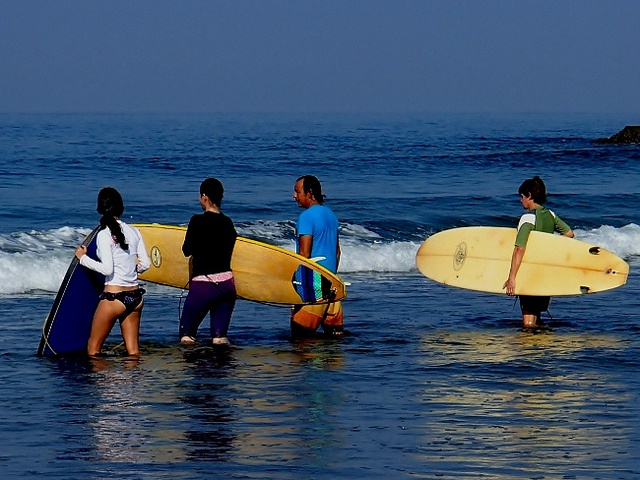Describe the objects in this image and their specific colors. I can see surfboard in blue, khaki, and tan tones, people in blue, black, lightgray, brown, and maroon tones, people in blue, black, lightpink, and navy tones, surfboard in blue, olive, tan, and orange tones, and people in blue, black, maroon, and gray tones in this image. 